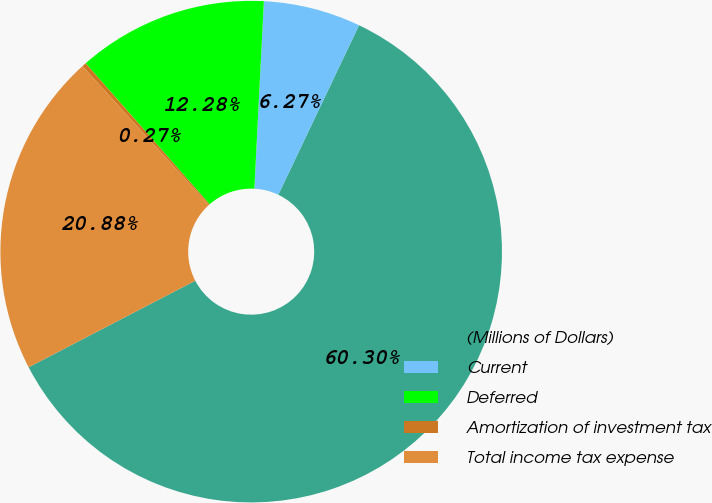<chart> <loc_0><loc_0><loc_500><loc_500><pie_chart><fcel>(Millions of Dollars)<fcel>Current<fcel>Deferred<fcel>Amortization of investment tax<fcel>Total income tax expense<nl><fcel>60.3%<fcel>6.27%<fcel>12.28%<fcel>0.27%<fcel>20.88%<nl></chart> 